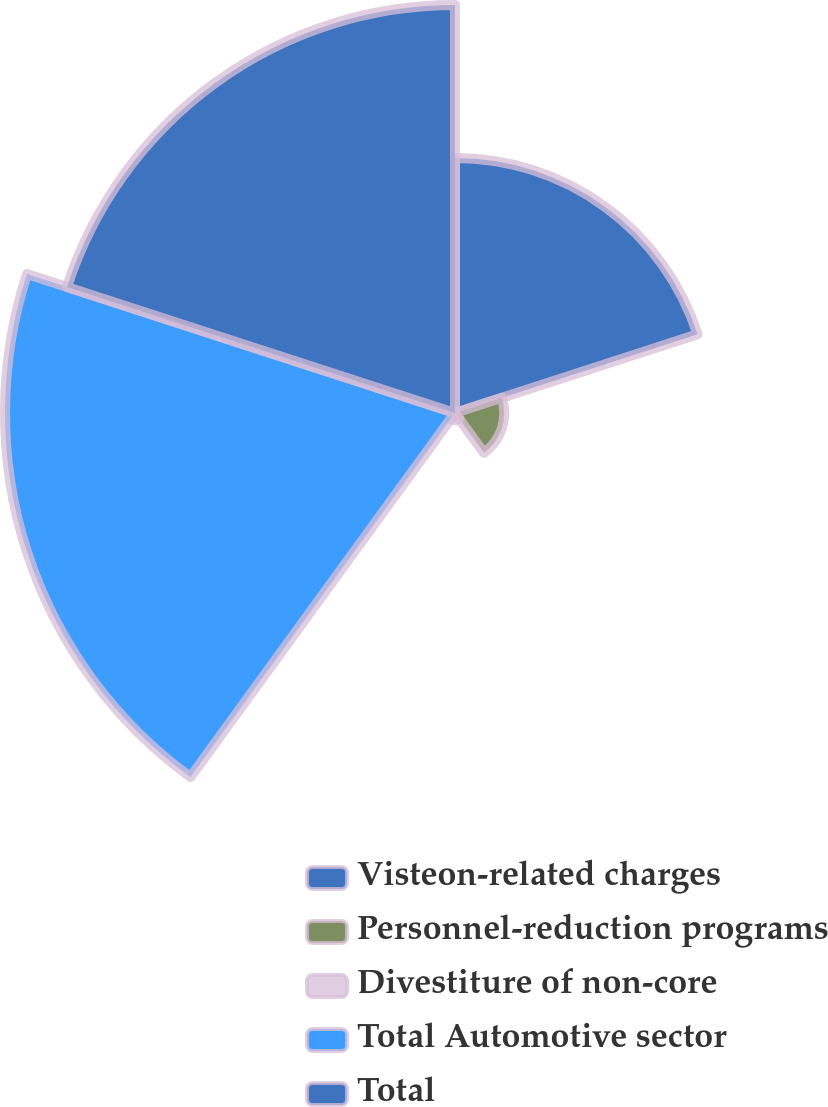Convert chart. <chart><loc_0><loc_0><loc_500><loc_500><pie_chart><fcel>Visteon-related charges<fcel>Personnel-reduction programs<fcel>Divestiture of non-core<fcel>Total Automotive sector<fcel>Total<nl><fcel>21.81%<fcel>4.21%<fcel>0.62%<fcel>38.48%<fcel>34.89%<nl></chart> 